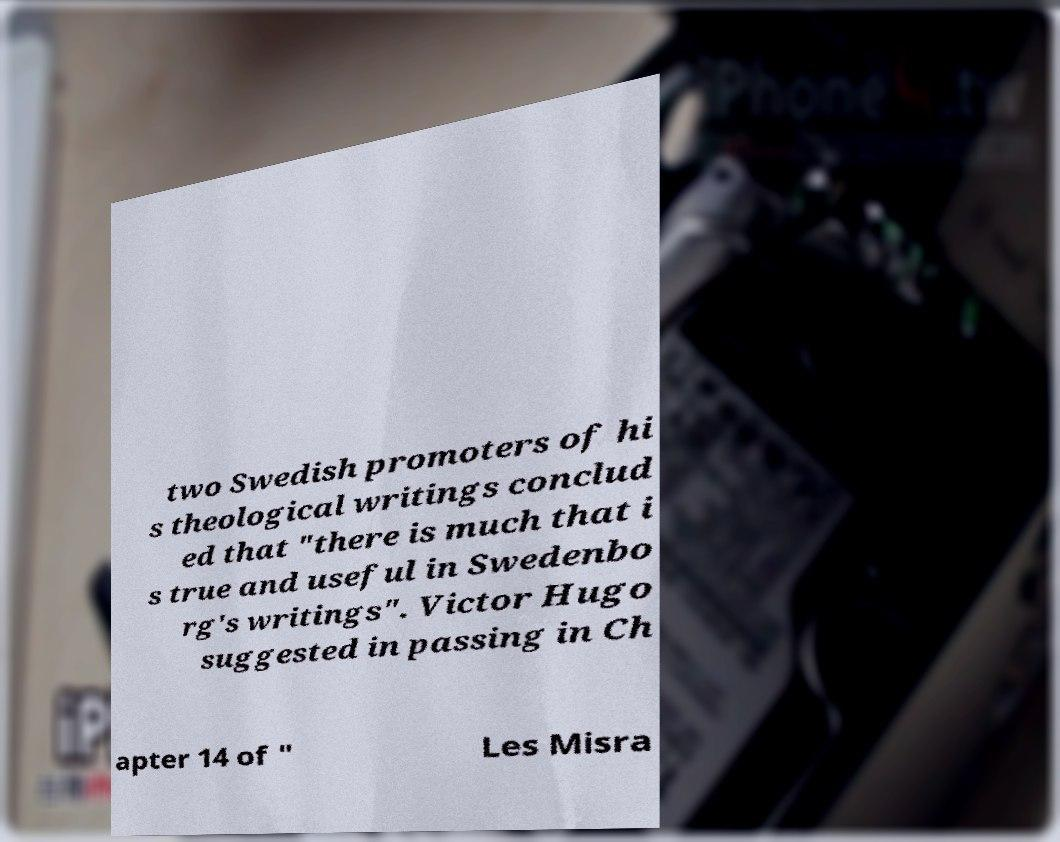Could you assist in decoding the text presented in this image and type it out clearly? two Swedish promoters of hi s theological writings conclud ed that "there is much that i s true and useful in Swedenbo rg's writings". Victor Hugo suggested in passing in Ch apter 14 of " Les Misra 